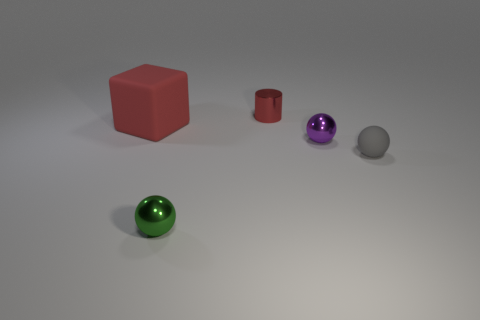Is the tiny purple sphere made of the same material as the tiny red cylinder?
Your answer should be very brief. Yes. What number of green objects have the same shape as the big red rubber thing?
Offer a very short reply. 0. There is a object that is made of the same material as the gray sphere; what shape is it?
Offer a very short reply. Cube. There is a matte object that is right of the small shiny object behind the small purple metallic ball; what is its color?
Give a very brief answer. Gray. Is the tiny rubber object the same color as the large cube?
Keep it short and to the point. No. What is the material of the red thing that is right of the shiny thing that is left of the red cylinder?
Offer a terse response. Metal. What material is the small purple thing that is the same shape as the green thing?
Offer a very short reply. Metal. Are there any large blocks on the right side of the tiny metallic thing that is in front of the rubber object that is on the right side of the big rubber cube?
Ensure brevity in your answer.  No. How many other objects are there of the same color as the large matte block?
Your answer should be compact. 1. What number of things are both behind the red rubber object and to the left of the small green sphere?
Provide a short and direct response. 0. 